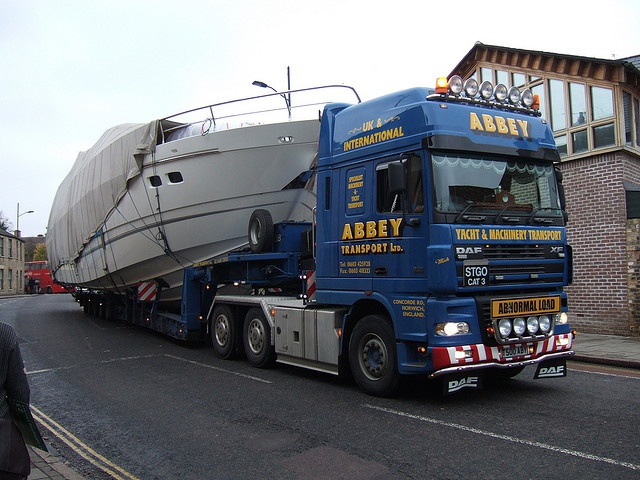Describe the objects in this image and their specific colors. I can see truck in lavender, black, navy, and gray tones, boat in lavender, darkgray, gray, white, and black tones, people in lavender, black, and gray tones, bus in lavender, maroon, brown, black, and gray tones, and people in lavender, black, and purple tones in this image. 